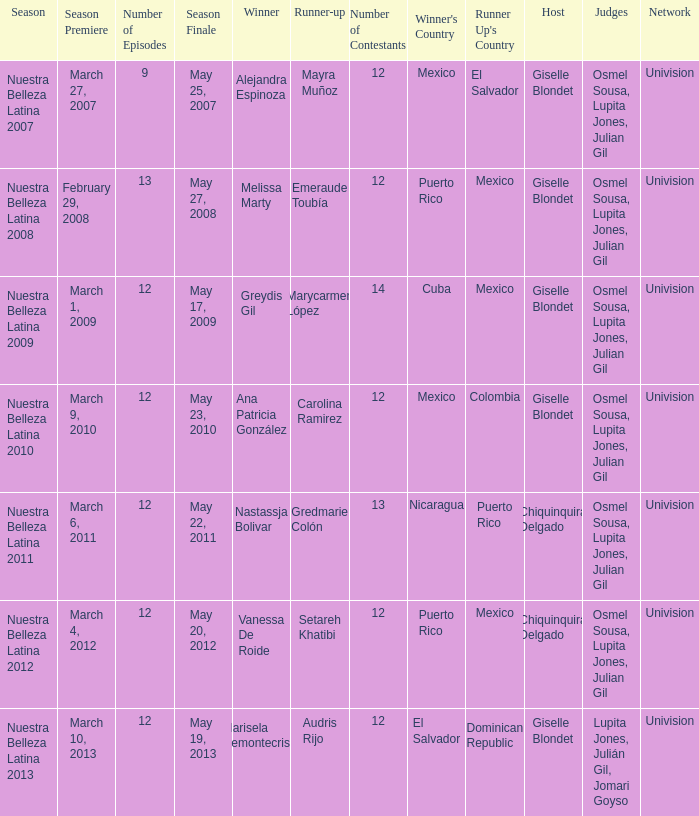What season had more than 12 contestants in which greydis gil won? Nuestra Belleza Latina 2009. 